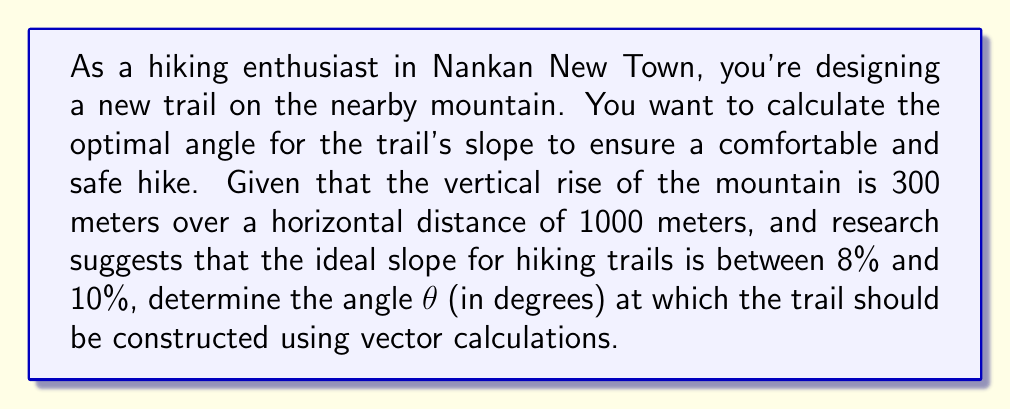Show me your answer to this math problem. Let's approach this step-by-step using vectors:

1) First, we can represent the trail as a vector $\vec{v}$ with horizontal and vertical components:

   $\vec{v} = \langle 1000, 300 \rangle$

2) The magnitude of this vector is:

   $|\vec{v}| = \sqrt{1000^2 + 300^2} = \sqrt{1,090,000} \approx 1044.03$ meters

3) The slope of a trail is typically calculated as the ratio of vertical rise to horizontal run:

   $\text{slope} = \frac{\text{rise}}{\text{run}} = \frac{300}{1000} = 0.3 = 30\%$

4) This is steeper than the ideal 8-10% range. We need to find an angle that will give us a slope in this range.

5) Let's aim for a 9% slope (middle of the ideal range). We can represent this as a vector $\vec{u}$:

   $\vec{u} = \langle 100, 9 \rangle$

6) The angle $\theta$ between $\vec{v}$ and $\vec{u}$ can be found using the dot product formula:

   $\cos \theta = \frac{\vec{v} \cdot \vec{u}}{|\vec{v}||\vec{u}|}$

7) Calculating the dot product:

   $\vec{v} \cdot \vec{u} = 1000(100) + 300(9) = 102,700$

8) The magnitude of $\vec{u}$:

   $|\vec{u}| = \sqrt{100^2 + 9^2} = \sqrt{10,081} \approx 100.40$

9) Substituting into the formula:

   $\cos \theta = \frac{102,700}{(1044.03)(100.40)} \approx 0.9789$

10) Taking the inverse cosine (arccos) and converting to degrees:

    $\theta = \arccos(0.9789) \approx 11.79°$

Therefore, the trail should be constructed at an angle of approximately 11.79° from the horizontal to achieve the optimal slope for hiking.
Answer: The optimal angle for the hiking trail slope is approximately $11.79°$. 